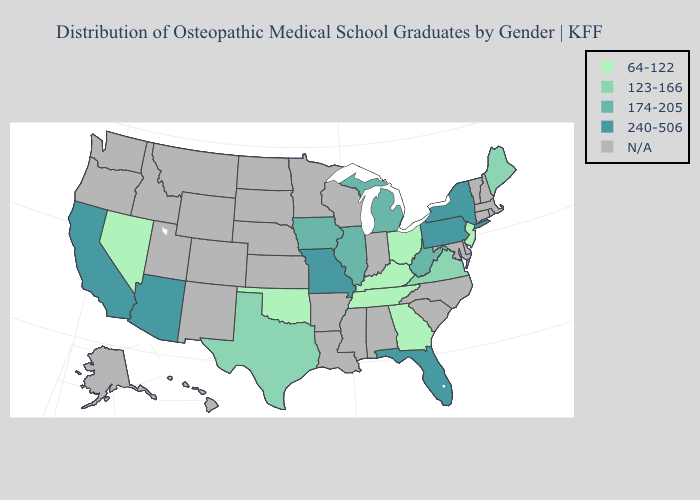How many symbols are there in the legend?
Keep it brief. 5. Name the states that have a value in the range 240-506?
Quick response, please. Arizona, California, Florida, Missouri, New York, Pennsylvania. Among the states that border Maryland , does West Virginia have the lowest value?
Answer briefly. No. Among the states that border New Mexico , which have the lowest value?
Concise answer only. Oklahoma. Name the states that have a value in the range N/A?
Be succinct. Alabama, Alaska, Arkansas, Colorado, Connecticut, Delaware, Hawaii, Idaho, Indiana, Kansas, Louisiana, Maryland, Massachusetts, Minnesota, Mississippi, Montana, Nebraska, New Hampshire, New Mexico, North Carolina, North Dakota, Oregon, Rhode Island, South Carolina, South Dakota, Utah, Vermont, Washington, Wisconsin, Wyoming. What is the value of Connecticut?
Concise answer only. N/A. What is the value of Vermont?
Keep it brief. N/A. What is the value of Delaware?
Write a very short answer. N/A. Does Pennsylvania have the highest value in the Northeast?
Write a very short answer. Yes. Does Maine have the highest value in the Northeast?
Give a very brief answer. No. Name the states that have a value in the range 240-506?
Answer briefly. Arizona, California, Florida, Missouri, New York, Pennsylvania. Does the map have missing data?
Write a very short answer. Yes. 